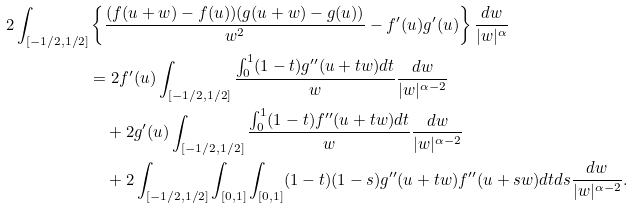<formula> <loc_0><loc_0><loc_500><loc_500>2 \int _ { [ - 1 / 2 , 1 / 2 ] } & \left \{ \frac { ( f ( u + w ) - f ( u ) ) ( g ( u + w ) - g ( u ) ) } { w ^ { 2 } } - f ^ { \prime } ( u ) g ^ { \prime } ( u ) \right \} \frac { d w } { | w | ^ { \alpha } } \\ & = 2 f ^ { \prime } ( u ) \int _ { [ - 1 / 2 , 1 / 2 ] } \frac { \int _ { 0 } ^ { 1 } ( 1 - t ) g ^ { \prime \prime } ( u + t w ) d t } { w } \frac { d w } { | w | ^ { \alpha - 2 } } \\ & \quad + 2 g ^ { \prime } ( u ) \int _ { [ - 1 / 2 , 1 / 2 ] } \frac { \int _ { 0 } ^ { 1 } ( 1 - t ) f ^ { \prime \prime } ( u + t w ) d t } { w } \frac { d w } { | w | ^ { \alpha - 2 } } \\ & \quad + 2 \int _ { [ - 1 / 2 , 1 / 2 ] } \int _ { [ 0 , 1 ] } \int _ { [ 0 , 1 ] } ( 1 - t ) ( 1 - s ) g ^ { \prime \prime } ( u + t w ) f ^ { \prime \prime } ( u + s w ) d t d s \frac { d w } { | w | ^ { \alpha - 2 } } .</formula> 